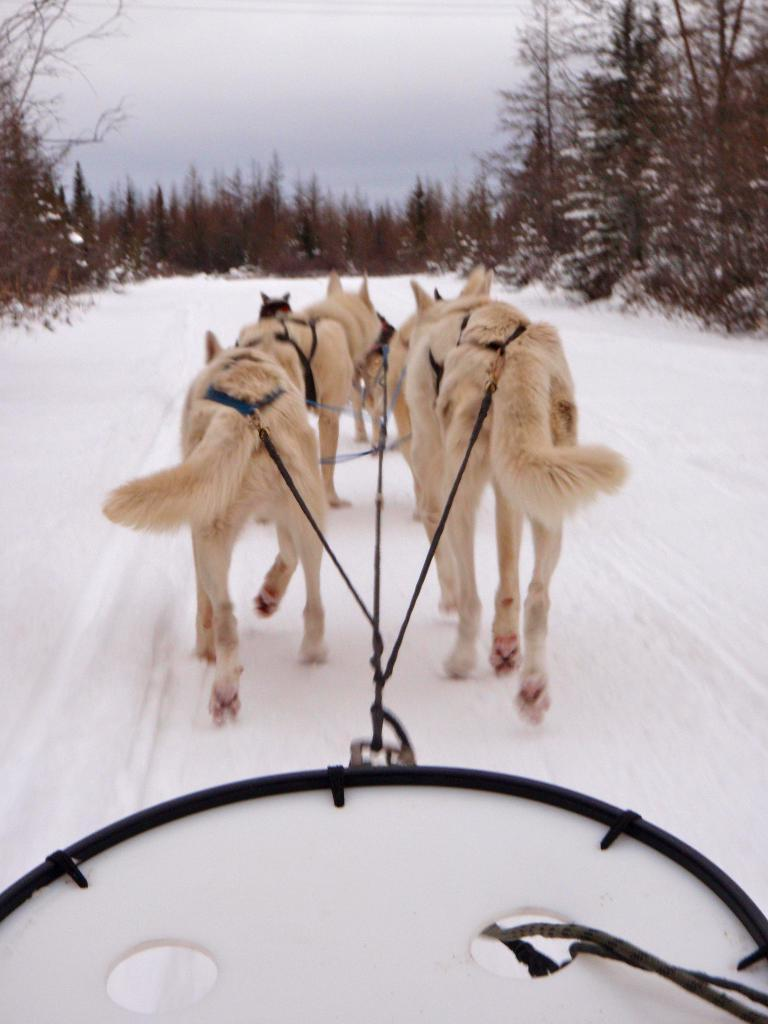What types of living organisms are in the image? There are animals in the image. What is connected to the animals? A cart is tied to the animals. What is the ground made of in the image? There is snow at the bottom of the image. What can be seen in the background of the image? There are plants and trees in the background of the image. What is visible at the top of the image? The sky is visible at the top of the image. What type of meat is being sold at the scene in the image? There is no scene or meat present in the image; it features animals with a cart and a snowy background. What kind of flower is growing near the trees in the image? There is no flower present near the trees in the image; only plants and trees are visible in the background. 